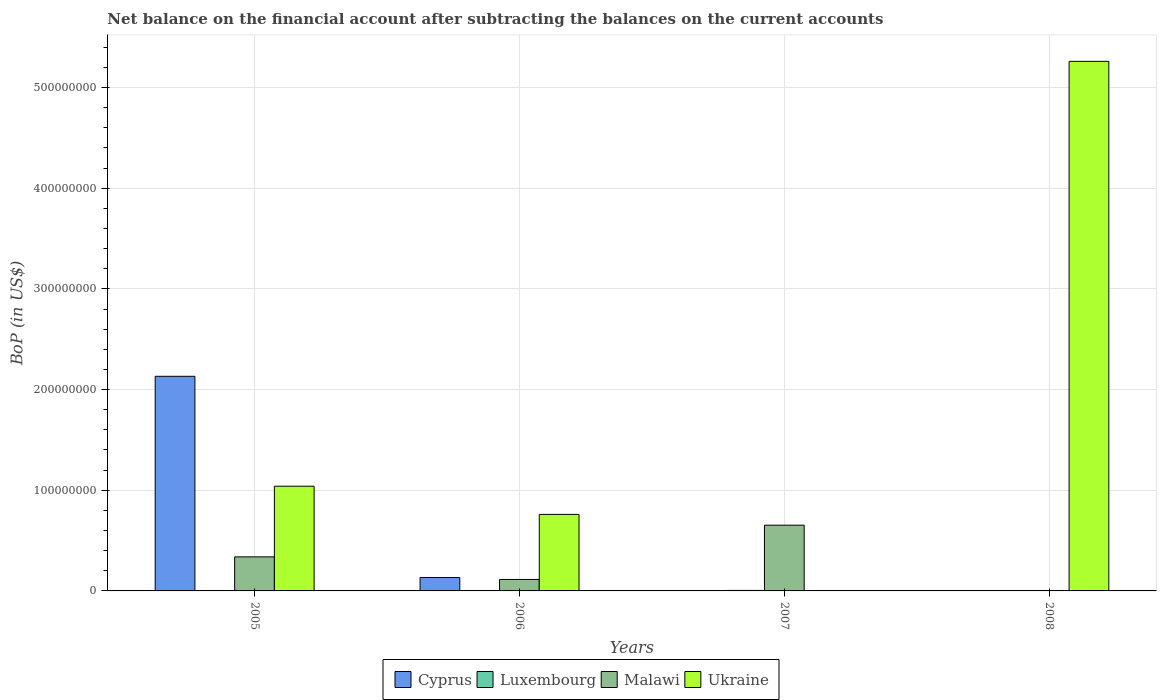How many different coloured bars are there?
Offer a very short reply. 4. Are the number of bars per tick equal to the number of legend labels?
Your answer should be very brief. No. Are the number of bars on each tick of the X-axis equal?
Your response must be concise. No. What is the label of the 2nd group of bars from the left?
Offer a terse response. 2006. What is the Balance of Payments in Ukraine in 2008?
Your answer should be very brief. 5.26e+08. Across all years, what is the maximum Balance of Payments in Ukraine?
Offer a terse response. 5.26e+08. In which year was the Balance of Payments in Cyprus maximum?
Keep it short and to the point. 2005. What is the total Balance of Payments in Cyprus in the graph?
Give a very brief answer. 2.27e+08. What is the difference between the Balance of Payments in Malawi in 2006 and that in 2007?
Offer a very short reply. -5.39e+07. What is the difference between the Balance of Payments in Cyprus in 2005 and the Balance of Payments in Luxembourg in 2006?
Provide a succinct answer. 2.13e+08. What is the average Balance of Payments in Malawi per year?
Offer a terse response. 2.76e+07. In the year 2007, what is the difference between the Balance of Payments in Malawi and Balance of Payments in Luxembourg?
Keep it short and to the point. 6.48e+07. In how many years, is the Balance of Payments in Luxembourg greater than 60000000 US$?
Offer a very short reply. 0. What is the ratio of the Balance of Payments in Cyprus in 2005 to that in 2006?
Offer a very short reply. 15.98. Is the Balance of Payments in Malawi in 2006 less than that in 2007?
Keep it short and to the point. Yes. What is the difference between the highest and the second highest Balance of Payments in Malawi?
Your response must be concise. 3.15e+07. What is the difference between the highest and the lowest Balance of Payments in Luxembourg?
Provide a succinct answer. 4.90e+05. In how many years, is the Balance of Payments in Ukraine greater than the average Balance of Payments in Ukraine taken over all years?
Keep it short and to the point. 1. Is the sum of the Balance of Payments in Ukraine in 2005 and 2006 greater than the maximum Balance of Payments in Malawi across all years?
Your response must be concise. Yes. Is it the case that in every year, the sum of the Balance of Payments in Malawi and Balance of Payments in Ukraine is greater than the Balance of Payments in Luxembourg?
Your response must be concise. Yes. How many bars are there?
Your response must be concise. 9. How many years are there in the graph?
Provide a succinct answer. 4. What is the difference between two consecutive major ticks on the Y-axis?
Offer a very short reply. 1.00e+08. Are the values on the major ticks of Y-axis written in scientific E-notation?
Your answer should be very brief. No. Does the graph contain any zero values?
Your answer should be compact. Yes. How are the legend labels stacked?
Give a very brief answer. Horizontal. What is the title of the graph?
Ensure brevity in your answer.  Net balance on the financial account after subtracting the balances on the current accounts. Does "Sweden" appear as one of the legend labels in the graph?
Provide a succinct answer. No. What is the label or title of the X-axis?
Offer a terse response. Years. What is the label or title of the Y-axis?
Give a very brief answer. BoP (in US$). What is the BoP (in US$) of Cyprus in 2005?
Offer a terse response. 2.13e+08. What is the BoP (in US$) of Luxembourg in 2005?
Provide a short and direct response. 0. What is the BoP (in US$) of Malawi in 2005?
Provide a succinct answer. 3.38e+07. What is the BoP (in US$) in Ukraine in 2005?
Your answer should be compact. 1.04e+08. What is the BoP (in US$) of Cyprus in 2006?
Keep it short and to the point. 1.33e+07. What is the BoP (in US$) of Malawi in 2006?
Offer a very short reply. 1.14e+07. What is the BoP (in US$) in Ukraine in 2006?
Offer a very short reply. 7.60e+07. What is the BoP (in US$) in Cyprus in 2007?
Offer a very short reply. 0. What is the BoP (in US$) in Luxembourg in 2007?
Your answer should be compact. 4.90e+05. What is the BoP (in US$) in Malawi in 2007?
Your answer should be compact. 6.53e+07. What is the BoP (in US$) in Luxembourg in 2008?
Make the answer very short. 0. What is the BoP (in US$) of Ukraine in 2008?
Your answer should be compact. 5.26e+08. Across all years, what is the maximum BoP (in US$) of Cyprus?
Your response must be concise. 2.13e+08. Across all years, what is the maximum BoP (in US$) in Luxembourg?
Offer a terse response. 4.90e+05. Across all years, what is the maximum BoP (in US$) of Malawi?
Give a very brief answer. 6.53e+07. Across all years, what is the maximum BoP (in US$) of Ukraine?
Provide a short and direct response. 5.26e+08. Across all years, what is the minimum BoP (in US$) of Cyprus?
Make the answer very short. 0. Across all years, what is the minimum BoP (in US$) in Luxembourg?
Provide a succinct answer. 0. What is the total BoP (in US$) in Cyprus in the graph?
Keep it short and to the point. 2.27e+08. What is the total BoP (in US$) in Luxembourg in the graph?
Make the answer very short. 4.90e+05. What is the total BoP (in US$) in Malawi in the graph?
Ensure brevity in your answer.  1.11e+08. What is the total BoP (in US$) in Ukraine in the graph?
Keep it short and to the point. 7.06e+08. What is the difference between the BoP (in US$) of Cyprus in 2005 and that in 2006?
Your answer should be very brief. 2.00e+08. What is the difference between the BoP (in US$) of Malawi in 2005 and that in 2006?
Provide a short and direct response. 2.24e+07. What is the difference between the BoP (in US$) in Ukraine in 2005 and that in 2006?
Ensure brevity in your answer.  2.80e+07. What is the difference between the BoP (in US$) of Malawi in 2005 and that in 2007?
Your answer should be very brief. -3.15e+07. What is the difference between the BoP (in US$) of Ukraine in 2005 and that in 2008?
Keep it short and to the point. -4.22e+08. What is the difference between the BoP (in US$) of Malawi in 2006 and that in 2007?
Give a very brief answer. -5.39e+07. What is the difference between the BoP (in US$) of Ukraine in 2006 and that in 2008?
Your answer should be compact. -4.50e+08. What is the difference between the BoP (in US$) in Cyprus in 2005 and the BoP (in US$) in Malawi in 2006?
Offer a terse response. 2.02e+08. What is the difference between the BoP (in US$) in Cyprus in 2005 and the BoP (in US$) in Ukraine in 2006?
Give a very brief answer. 1.37e+08. What is the difference between the BoP (in US$) in Malawi in 2005 and the BoP (in US$) in Ukraine in 2006?
Your response must be concise. -4.22e+07. What is the difference between the BoP (in US$) of Cyprus in 2005 and the BoP (in US$) of Luxembourg in 2007?
Give a very brief answer. 2.13e+08. What is the difference between the BoP (in US$) in Cyprus in 2005 and the BoP (in US$) in Malawi in 2007?
Offer a very short reply. 1.48e+08. What is the difference between the BoP (in US$) of Cyprus in 2005 and the BoP (in US$) of Ukraine in 2008?
Offer a terse response. -3.13e+08. What is the difference between the BoP (in US$) in Malawi in 2005 and the BoP (in US$) in Ukraine in 2008?
Provide a succinct answer. -4.92e+08. What is the difference between the BoP (in US$) of Cyprus in 2006 and the BoP (in US$) of Luxembourg in 2007?
Your answer should be very brief. 1.28e+07. What is the difference between the BoP (in US$) in Cyprus in 2006 and the BoP (in US$) in Malawi in 2007?
Keep it short and to the point. -5.20e+07. What is the difference between the BoP (in US$) of Cyprus in 2006 and the BoP (in US$) of Ukraine in 2008?
Ensure brevity in your answer.  -5.13e+08. What is the difference between the BoP (in US$) in Malawi in 2006 and the BoP (in US$) in Ukraine in 2008?
Ensure brevity in your answer.  -5.15e+08. What is the difference between the BoP (in US$) of Luxembourg in 2007 and the BoP (in US$) of Ukraine in 2008?
Make the answer very short. -5.26e+08. What is the difference between the BoP (in US$) of Malawi in 2007 and the BoP (in US$) of Ukraine in 2008?
Offer a very short reply. -4.61e+08. What is the average BoP (in US$) in Cyprus per year?
Provide a short and direct response. 5.66e+07. What is the average BoP (in US$) in Luxembourg per year?
Ensure brevity in your answer.  1.23e+05. What is the average BoP (in US$) of Malawi per year?
Provide a succinct answer. 2.76e+07. What is the average BoP (in US$) of Ukraine per year?
Provide a succinct answer. 1.76e+08. In the year 2005, what is the difference between the BoP (in US$) in Cyprus and BoP (in US$) in Malawi?
Your response must be concise. 1.79e+08. In the year 2005, what is the difference between the BoP (in US$) in Cyprus and BoP (in US$) in Ukraine?
Provide a succinct answer. 1.09e+08. In the year 2005, what is the difference between the BoP (in US$) of Malawi and BoP (in US$) of Ukraine?
Give a very brief answer. -7.02e+07. In the year 2006, what is the difference between the BoP (in US$) of Cyprus and BoP (in US$) of Malawi?
Ensure brevity in your answer.  1.94e+06. In the year 2006, what is the difference between the BoP (in US$) of Cyprus and BoP (in US$) of Ukraine?
Offer a very short reply. -6.27e+07. In the year 2006, what is the difference between the BoP (in US$) in Malawi and BoP (in US$) in Ukraine?
Give a very brief answer. -6.46e+07. In the year 2007, what is the difference between the BoP (in US$) in Luxembourg and BoP (in US$) in Malawi?
Provide a short and direct response. -6.48e+07. What is the ratio of the BoP (in US$) of Cyprus in 2005 to that in 2006?
Offer a terse response. 15.98. What is the ratio of the BoP (in US$) in Malawi in 2005 to that in 2006?
Provide a succinct answer. 2.97. What is the ratio of the BoP (in US$) of Ukraine in 2005 to that in 2006?
Your answer should be very brief. 1.37. What is the ratio of the BoP (in US$) in Malawi in 2005 to that in 2007?
Ensure brevity in your answer.  0.52. What is the ratio of the BoP (in US$) in Ukraine in 2005 to that in 2008?
Provide a short and direct response. 0.2. What is the ratio of the BoP (in US$) in Malawi in 2006 to that in 2007?
Your answer should be compact. 0.17. What is the ratio of the BoP (in US$) in Ukraine in 2006 to that in 2008?
Offer a very short reply. 0.14. What is the difference between the highest and the second highest BoP (in US$) in Malawi?
Ensure brevity in your answer.  3.15e+07. What is the difference between the highest and the second highest BoP (in US$) in Ukraine?
Make the answer very short. 4.22e+08. What is the difference between the highest and the lowest BoP (in US$) in Cyprus?
Keep it short and to the point. 2.13e+08. What is the difference between the highest and the lowest BoP (in US$) of Luxembourg?
Your answer should be compact. 4.90e+05. What is the difference between the highest and the lowest BoP (in US$) in Malawi?
Your answer should be very brief. 6.53e+07. What is the difference between the highest and the lowest BoP (in US$) of Ukraine?
Offer a terse response. 5.26e+08. 